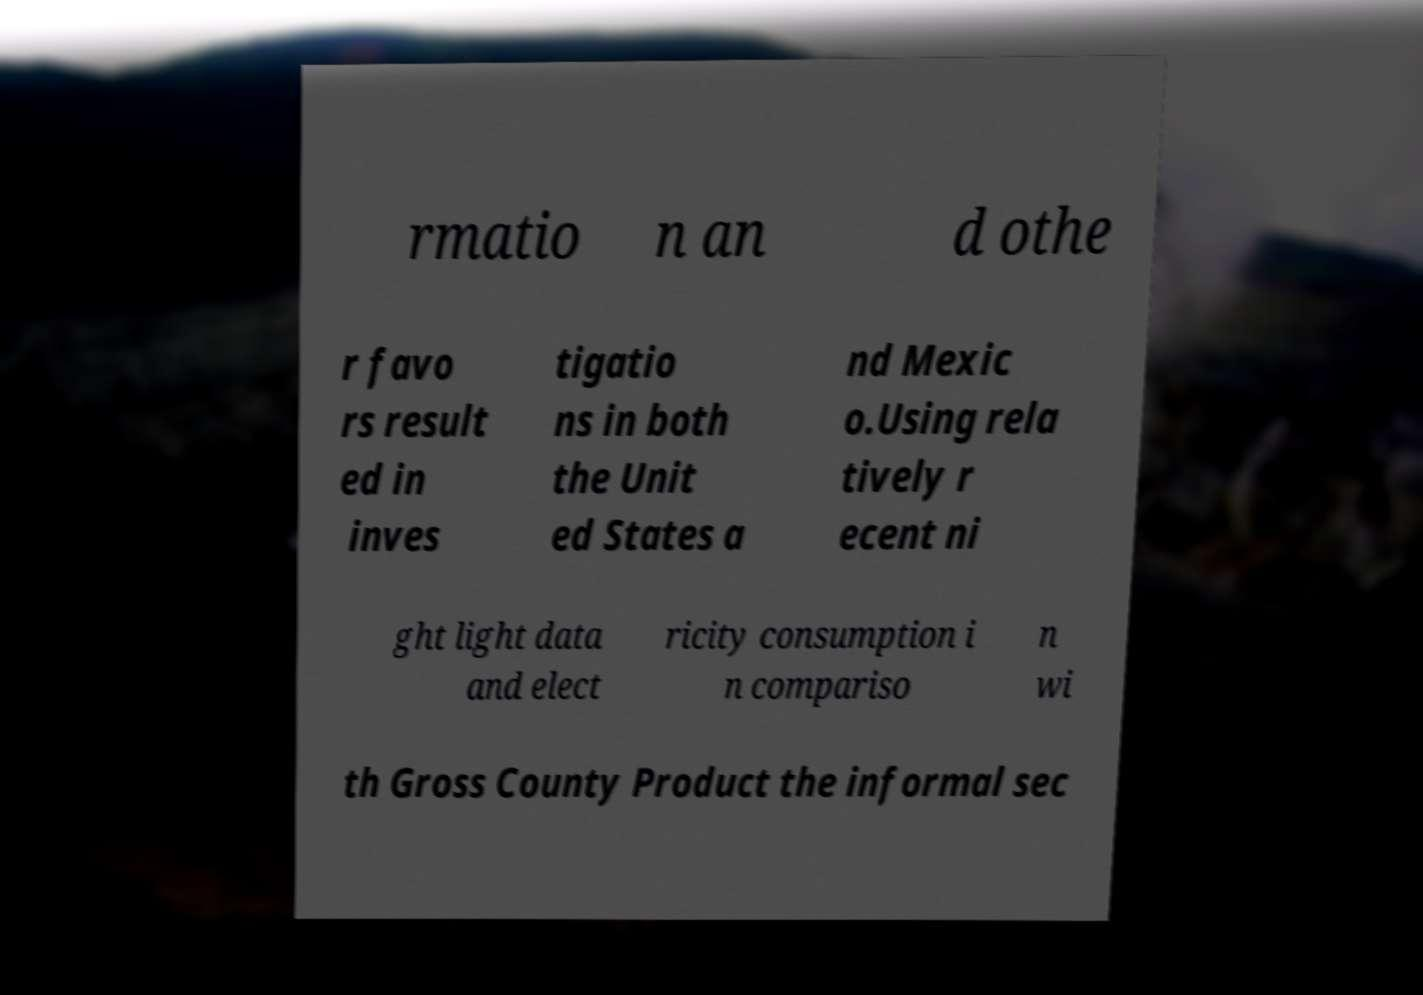Could you assist in decoding the text presented in this image and type it out clearly? rmatio n an d othe r favo rs result ed in inves tigatio ns in both the Unit ed States a nd Mexic o.Using rela tively r ecent ni ght light data and elect ricity consumption i n compariso n wi th Gross County Product the informal sec 